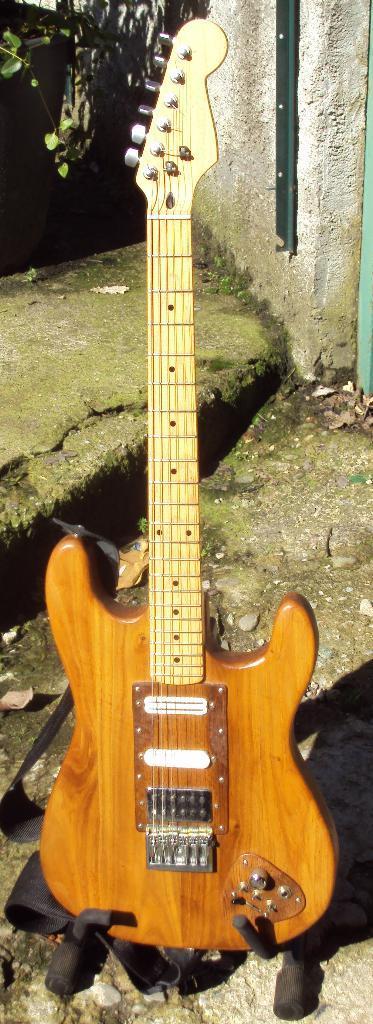Please provide a concise description of this image. This picture shows a guitar 